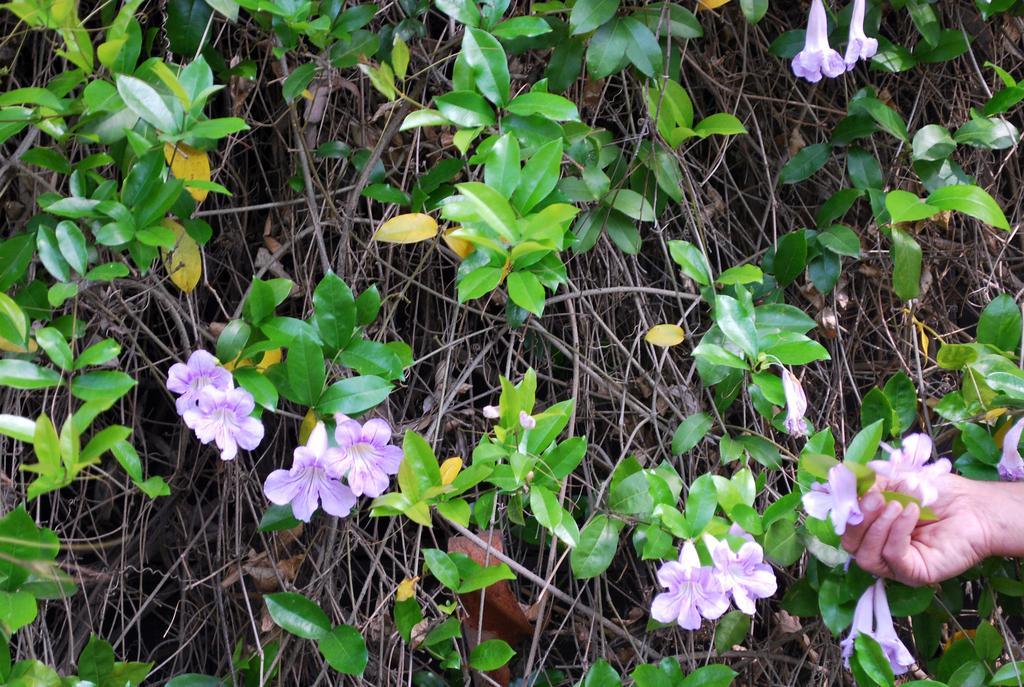What type of plant life can be seen in the image? There are flowers, leaves, and stems in the image. Can you describe the parts of the plants that are visible? The flowers, leaves, and stems are visible in the image. Is there any indication of human presence in the image? Yes, a hand of a person is visible in the bottom right side of the image. What type of cheese is being held by the giraffe in the image? There is no giraffe or cheese present in the image. 